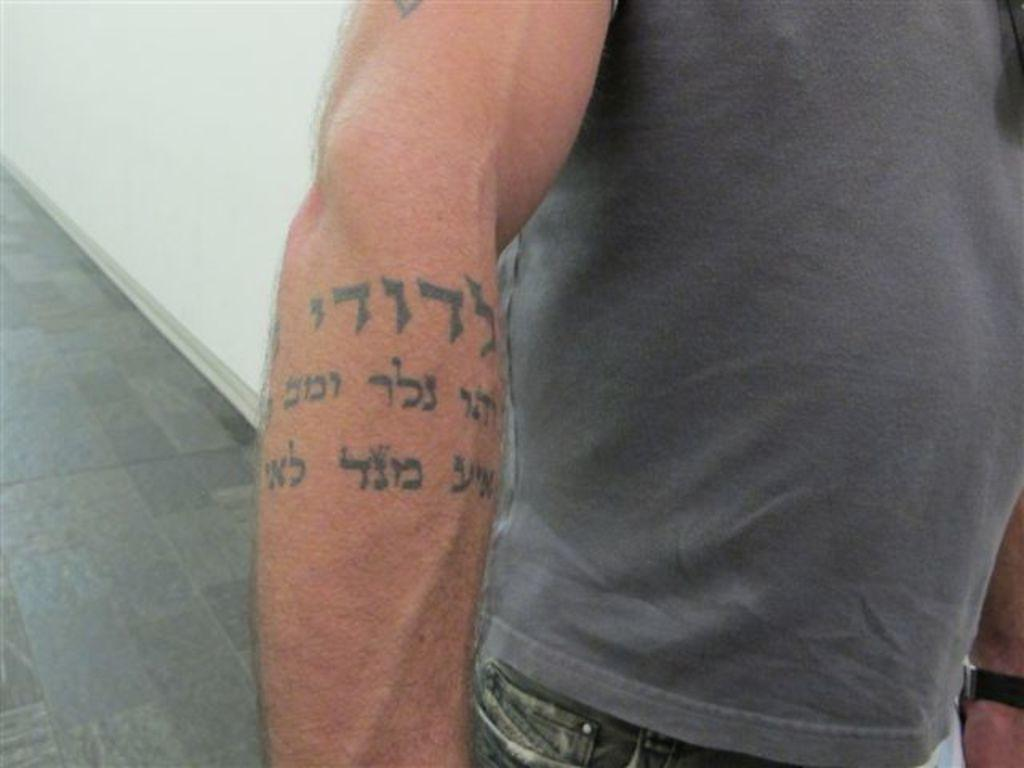Who or what is present in the image? There is a person in the image. What distinguishing feature can be seen on the person's hand? The person has a tattoo on their hand. What is located beside the person? There is a wall beside the person. What part of the room can be seen to the left of the person? The floor is visible to the left of the person. How many lizards are crawling on the wall in the image? There are no lizards present in the image; only a person and a wall are visible. 